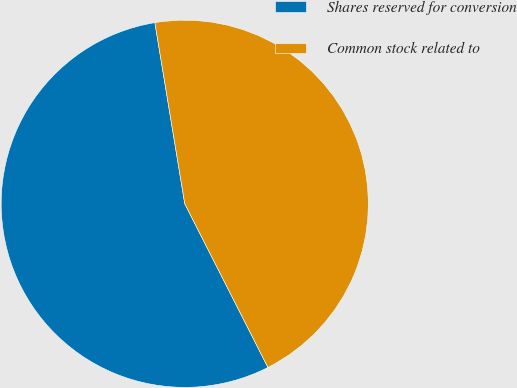Convert chart. <chart><loc_0><loc_0><loc_500><loc_500><pie_chart><fcel>Shares reserved for conversion<fcel>Common stock related to<nl><fcel>54.88%<fcel>45.12%<nl></chart> 